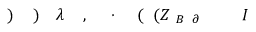Convert formula to latex. <formula><loc_0><loc_0><loc_500><loc_500>I \, _ { \, \partial \, B } \, ( Z \, ( \, \cdot \, , \, \lambda \, ) \, ) \,</formula> 